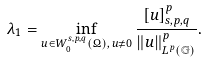Convert formula to latex. <formula><loc_0><loc_0><loc_500><loc_500>\lambda _ { 1 } = \inf _ { u \in W _ { 0 } ^ { s , p , q } ( \Omega ) , \, u \neq 0 } \frac { [ u ] ^ { p } _ { s , p , q } } { \| u \| ^ { p } _ { L ^ { p } ( \mathbb { G } ) } } .</formula> 